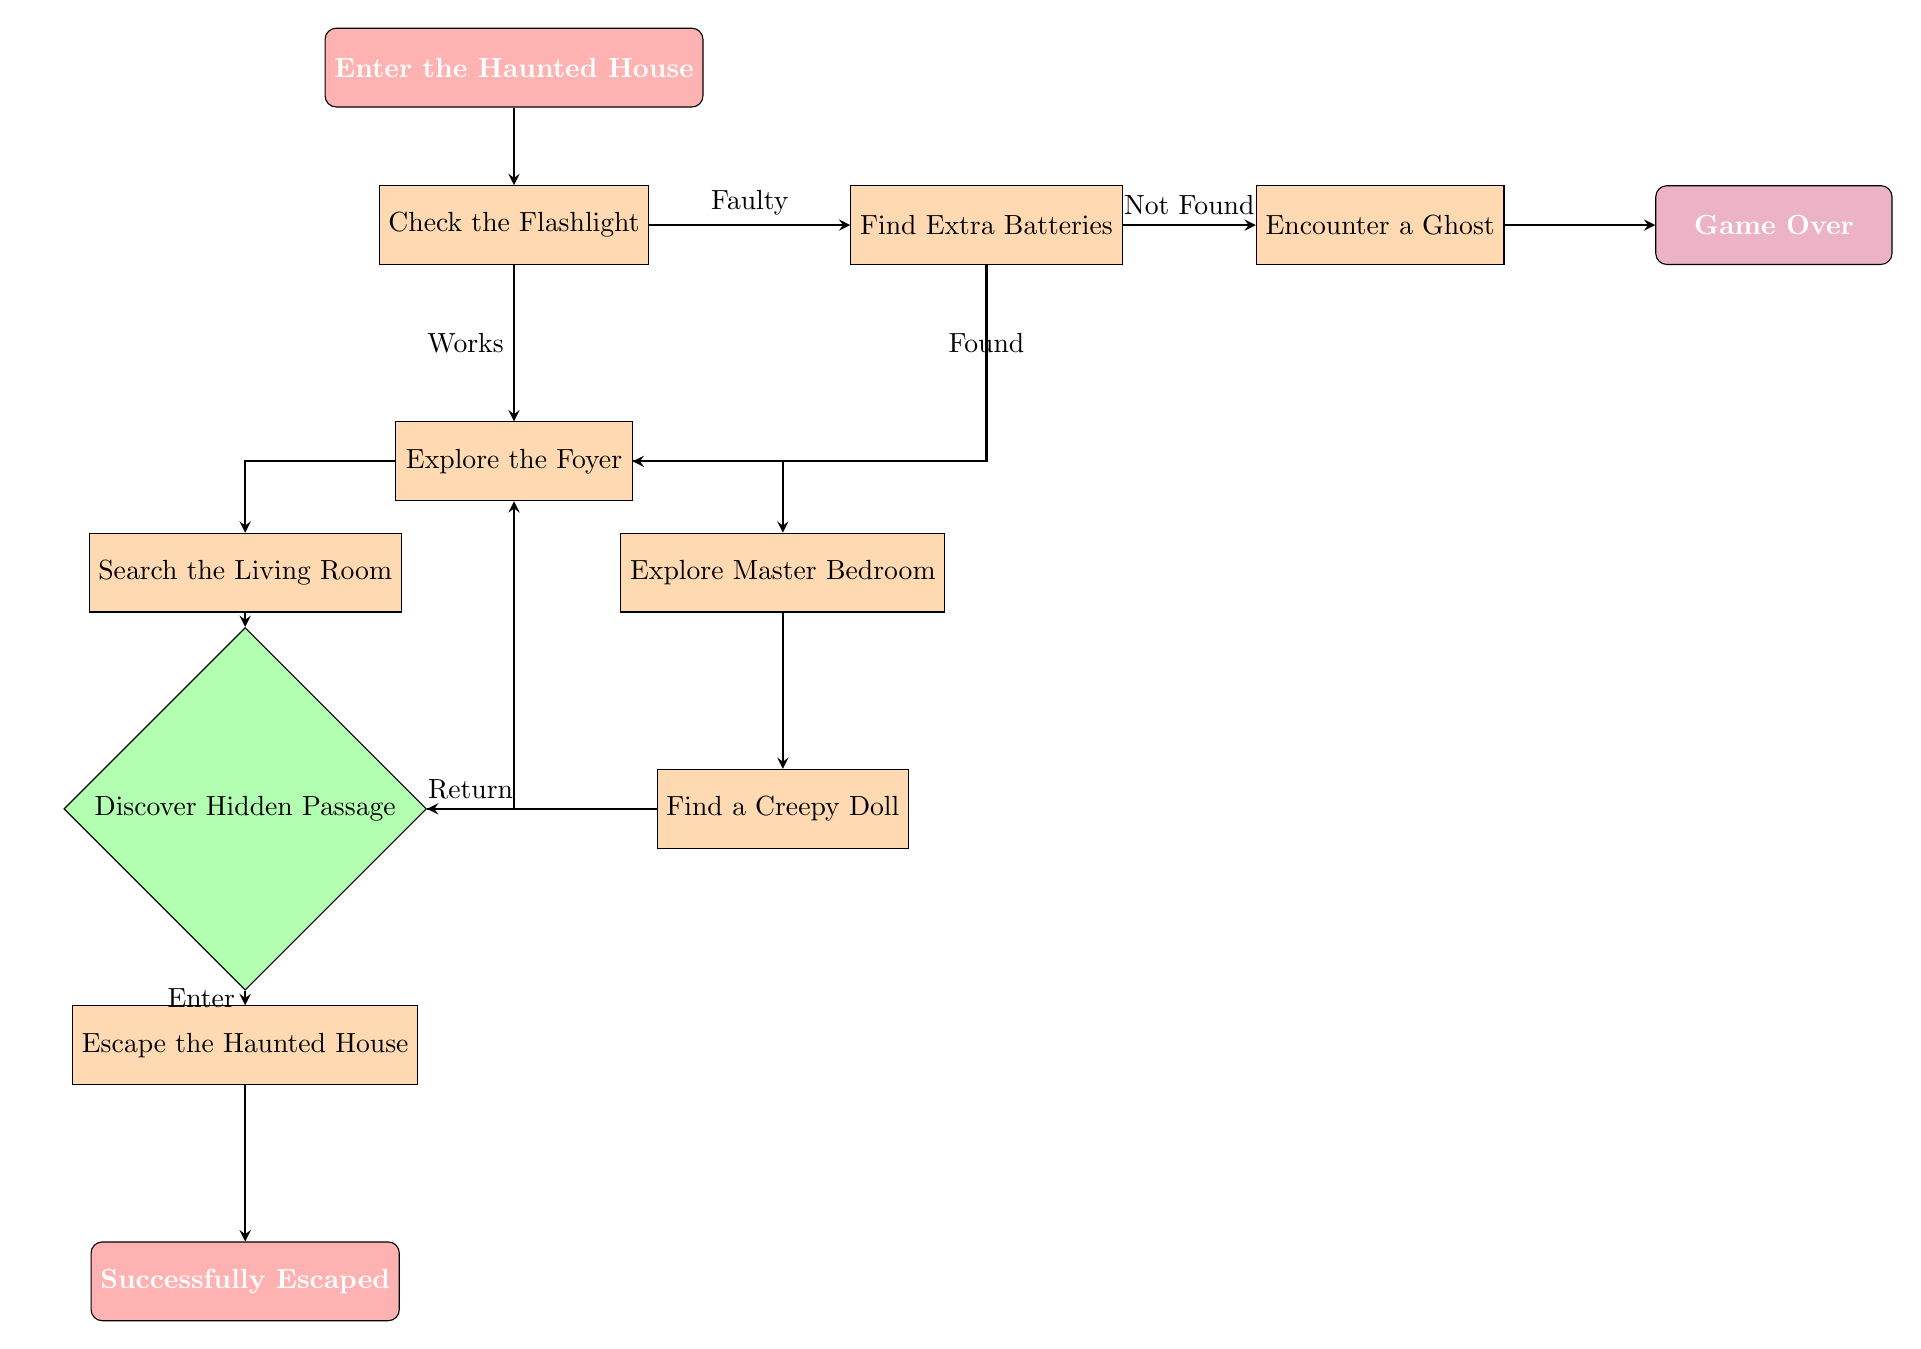What is the first action taken upon entering the haunted house? The first action indicated in the flow chart is to "Check the Flashlight" after entering the haunted house.
Answer: Check the Flashlight How many total nodes are in this diagram? The diagram consists of 9 process nodes, plus the starting and ending nodes, which totals 11 nodes.
Answer: 11 What happens if the flashlight is faulty? If the flashlight is faulty, the next action is to "Find Extra Batteries" as indicated by the decision made in the flow chart.
Answer: Find Extra Batteries What do you encounter if batteries are not found? If batteries are not found, the diagram indicates that you will "Encounter a Ghost."
Answer: Encounter a Ghost If you explore the foyer and choose to go upstairs, which node will you reach next? After choosing to go upstairs, you will reach the node labeled "Explore the Master Bedroom" as stated in the flow chart.
Answer: Explore the Master Bedroom What choice leads to the hidden passage? The choice that leads to the hidden passage is to "Search the Living Room" and subsequently find an old diary, which allows you to discover the hidden passage.
Answer: Search the Living Room How do you escape the haunted house? You can escape the haunted house by choosing either to leave through the back door or to use the main entrance after discovering the hidden passage.
Answer: Leave through Back Door or Use Main Entrance What are the two options if you find a creepy doll? If you find a creepy doll, you have the options to either "Inspect the Doll" or "Ignore the Doll."
Answer: Inspect the Doll or Ignore the Doll What action leads to the game over state? The action that leads to the game over state is either "Try to Escape" or "Confront the Ghost" upon encountering a ghost.
Answer: Try to Escape or Confront the Ghost 